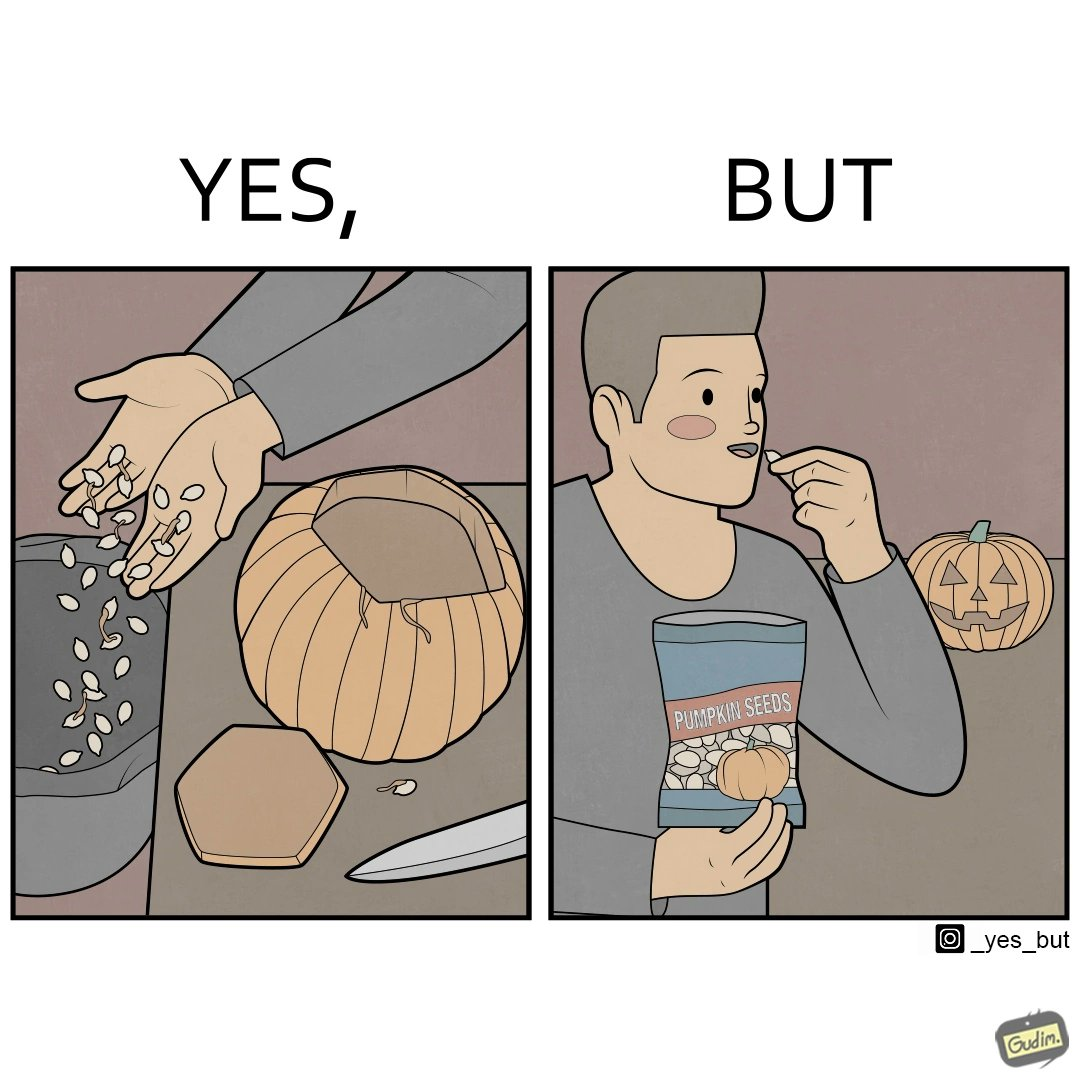Is this a satirical image? Yes, this image is satirical. 